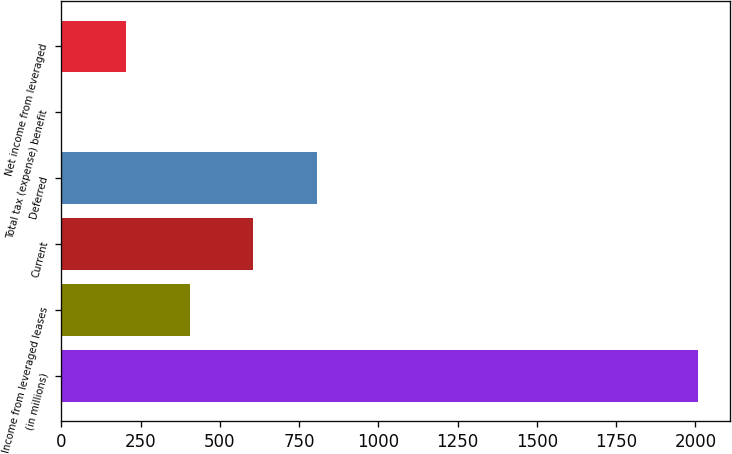Convert chart to OTSL. <chart><loc_0><loc_0><loc_500><loc_500><bar_chart><fcel>(in millions)<fcel>Income from leveraged leases<fcel>Current<fcel>Deferred<fcel>Total tax (expense) benefit<fcel>Net income from leveraged<nl><fcel>2009<fcel>404.2<fcel>604.8<fcel>805.4<fcel>3<fcel>203.6<nl></chart> 